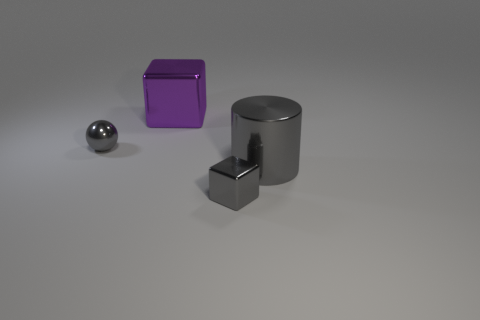Add 4 tiny brown spheres. How many objects exist? 8 Add 4 spheres. How many spheres are left? 5 Add 4 big purple metallic things. How many big purple metallic things exist? 5 Subtract 0 red balls. How many objects are left? 4 Subtract all large metal blocks. Subtract all tiny gray balls. How many objects are left? 2 